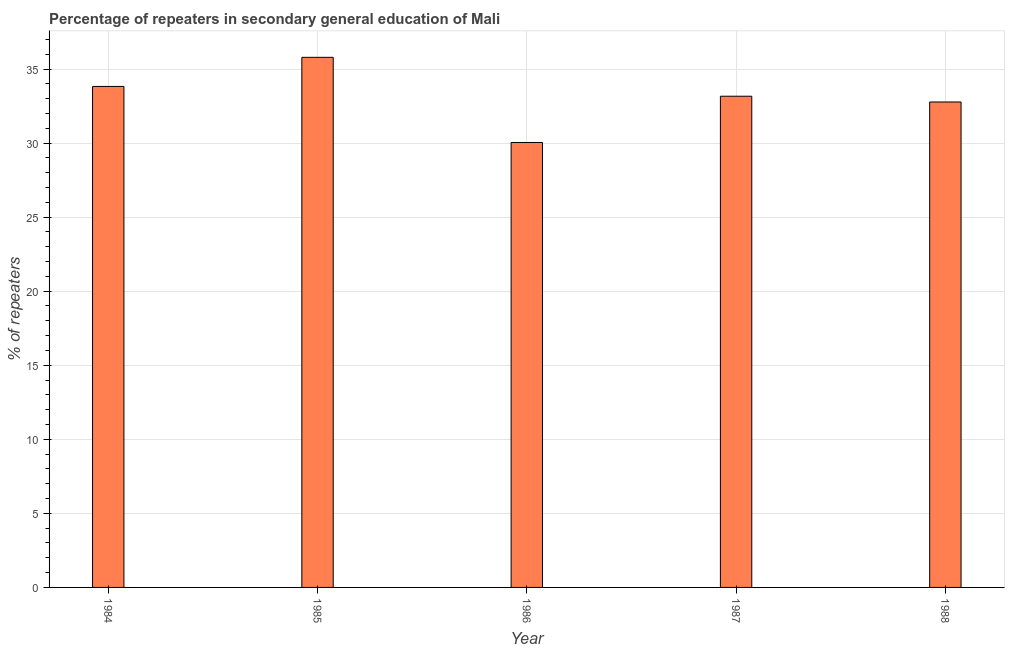What is the title of the graph?
Your answer should be very brief. Percentage of repeaters in secondary general education of Mali. What is the label or title of the Y-axis?
Your answer should be very brief. % of repeaters. What is the percentage of repeaters in 1986?
Keep it short and to the point. 30.04. Across all years, what is the maximum percentage of repeaters?
Give a very brief answer. 35.79. Across all years, what is the minimum percentage of repeaters?
Your response must be concise. 30.04. In which year was the percentage of repeaters maximum?
Keep it short and to the point. 1985. In which year was the percentage of repeaters minimum?
Provide a short and direct response. 1986. What is the sum of the percentage of repeaters?
Make the answer very short. 165.59. What is the difference between the percentage of repeaters in 1985 and 1987?
Your response must be concise. 2.63. What is the average percentage of repeaters per year?
Your answer should be very brief. 33.12. What is the median percentage of repeaters?
Offer a terse response. 33.16. In how many years, is the percentage of repeaters greater than 17 %?
Give a very brief answer. 5. Do a majority of the years between 1984 and 1988 (inclusive) have percentage of repeaters greater than 36 %?
Give a very brief answer. No. What is the ratio of the percentage of repeaters in 1986 to that in 1987?
Provide a succinct answer. 0.91. Is the percentage of repeaters in 1984 less than that in 1988?
Offer a very short reply. No. What is the difference between the highest and the second highest percentage of repeaters?
Provide a short and direct response. 1.97. Is the sum of the percentage of repeaters in 1984 and 1986 greater than the maximum percentage of repeaters across all years?
Offer a very short reply. Yes. What is the difference between the highest and the lowest percentage of repeaters?
Your answer should be compact. 5.75. How many bars are there?
Offer a very short reply. 5. Are all the bars in the graph horizontal?
Offer a terse response. No. How many years are there in the graph?
Your answer should be very brief. 5. What is the % of repeaters in 1984?
Provide a succinct answer. 33.82. What is the % of repeaters in 1985?
Your answer should be very brief. 35.79. What is the % of repeaters of 1986?
Your answer should be very brief. 30.04. What is the % of repeaters of 1987?
Offer a terse response. 33.16. What is the % of repeaters of 1988?
Offer a terse response. 32.77. What is the difference between the % of repeaters in 1984 and 1985?
Your answer should be very brief. -1.96. What is the difference between the % of repeaters in 1984 and 1986?
Your answer should be compact. 3.78. What is the difference between the % of repeaters in 1984 and 1987?
Your response must be concise. 0.66. What is the difference between the % of repeaters in 1984 and 1988?
Give a very brief answer. 1.05. What is the difference between the % of repeaters in 1985 and 1986?
Keep it short and to the point. 5.75. What is the difference between the % of repeaters in 1985 and 1987?
Offer a terse response. 2.63. What is the difference between the % of repeaters in 1985 and 1988?
Provide a short and direct response. 3.01. What is the difference between the % of repeaters in 1986 and 1987?
Offer a very short reply. -3.12. What is the difference between the % of repeaters in 1986 and 1988?
Ensure brevity in your answer.  -2.74. What is the difference between the % of repeaters in 1987 and 1988?
Your response must be concise. 0.39. What is the ratio of the % of repeaters in 1984 to that in 1985?
Give a very brief answer. 0.94. What is the ratio of the % of repeaters in 1984 to that in 1986?
Your answer should be very brief. 1.13. What is the ratio of the % of repeaters in 1984 to that in 1988?
Provide a short and direct response. 1.03. What is the ratio of the % of repeaters in 1985 to that in 1986?
Your response must be concise. 1.19. What is the ratio of the % of repeaters in 1985 to that in 1987?
Keep it short and to the point. 1.08. What is the ratio of the % of repeaters in 1985 to that in 1988?
Your answer should be compact. 1.09. What is the ratio of the % of repeaters in 1986 to that in 1987?
Offer a very short reply. 0.91. What is the ratio of the % of repeaters in 1986 to that in 1988?
Your answer should be compact. 0.92. What is the ratio of the % of repeaters in 1987 to that in 1988?
Offer a very short reply. 1.01. 